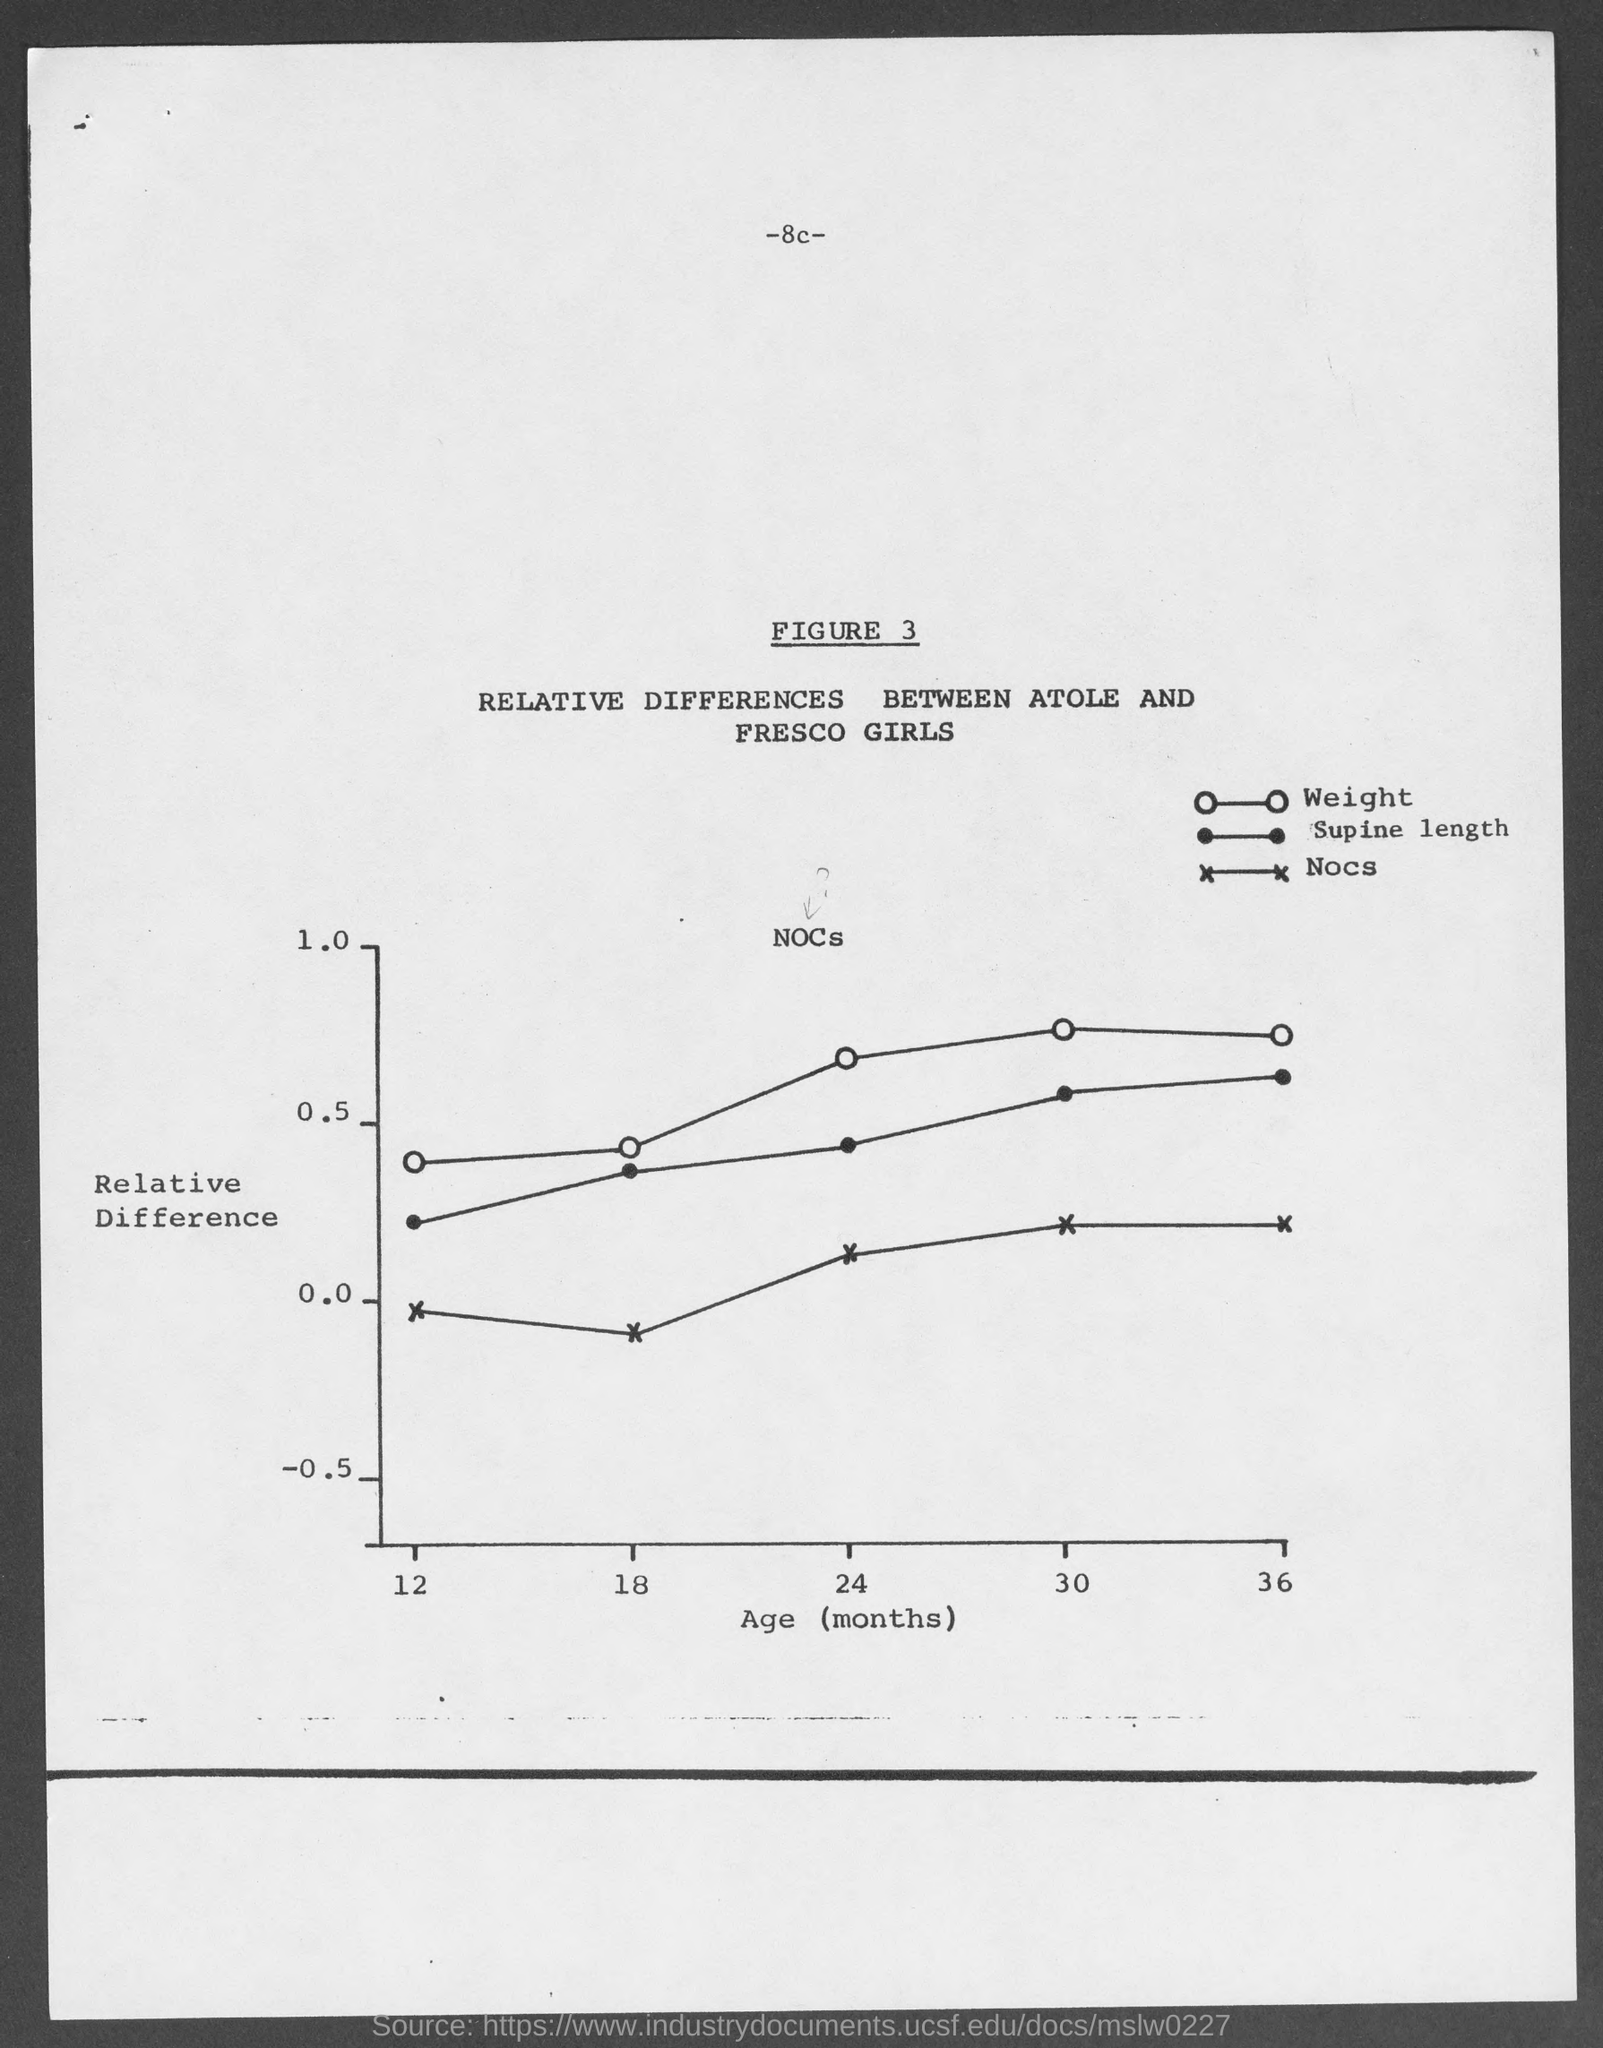what is the figure no.? The figure number displayed in the image is Figure 3, which is titled 'RELATIVE DIFFERENCES BETWEEN ATOLE AND FRESCO GIRLS' and plots data on weight, supine length, and nocs against age in months. 